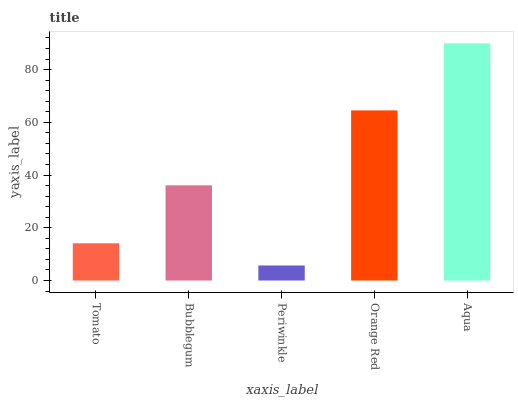Is Periwinkle the minimum?
Answer yes or no. Yes. Is Aqua the maximum?
Answer yes or no. Yes. Is Bubblegum the minimum?
Answer yes or no. No. Is Bubblegum the maximum?
Answer yes or no. No. Is Bubblegum greater than Tomato?
Answer yes or no. Yes. Is Tomato less than Bubblegum?
Answer yes or no. Yes. Is Tomato greater than Bubblegum?
Answer yes or no. No. Is Bubblegum less than Tomato?
Answer yes or no. No. Is Bubblegum the high median?
Answer yes or no. Yes. Is Bubblegum the low median?
Answer yes or no. Yes. Is Aqua the high median?
Answer yes or no. No. Is Aqua the low median?
Answer yes or no. No. 